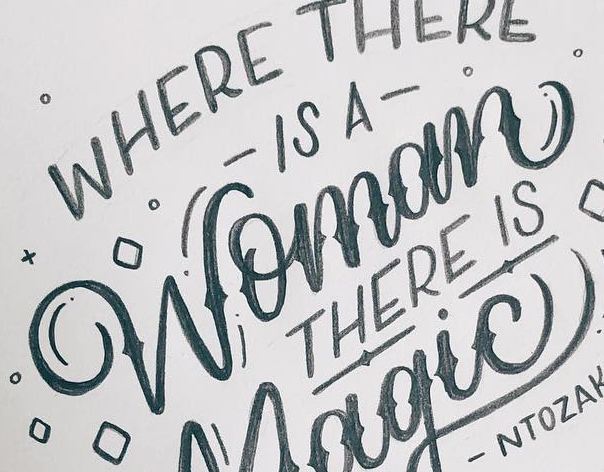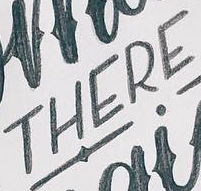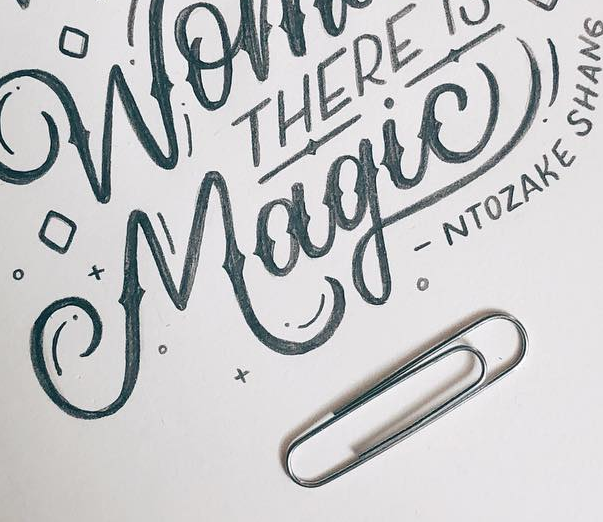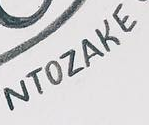Transcribe the words shown in these images in order, separated by a semicolon. Womom; THERE; Magic!; NTOZAKE 